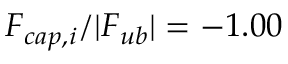<formula> <loc_0><loc_0><loc_500><loc_500>F _ { c a p , i } / | F _ { u b } | = - 1 . 0 0</formula> 